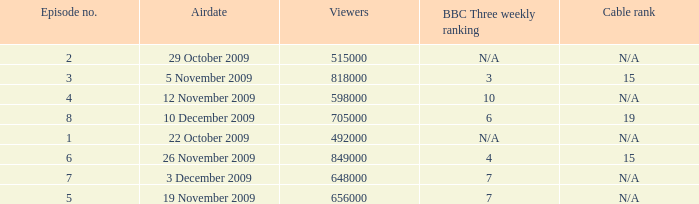What is the cable rank for bbc three weekly ranking of n/a? N/A, N/A. 